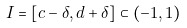Convert formula to latex. <formula><loc_0><loc_0><loc_500><loc_500>I = \left [ c - \delta , d + \delta \right ] \subset \left ( - 1 , 1 \right )</formula> 